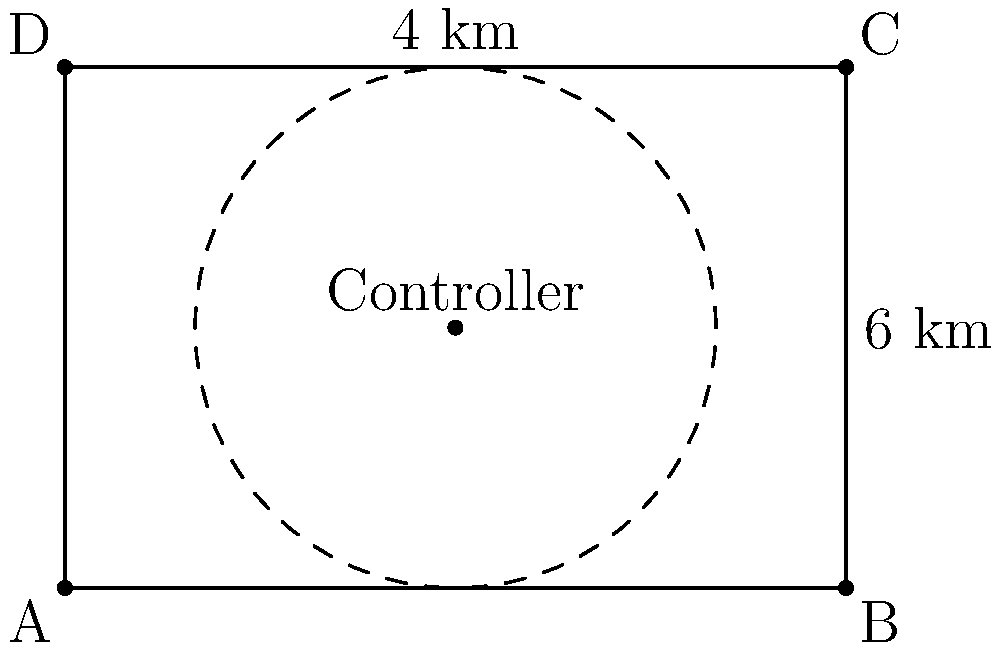In a rectangular SDN deployment area measuring 6 km by 4 km, a single SDN controller is placed at the center. Assuming the controller can effectively manage switches within a 2 km radius, what percentage of the total area is covered by the controller? Round your answer to the nearest whole percent. To solve this problem, we need to follow these steps:

1. Calculate the total area of the rectangle:
   Area of rectangle = length × width
   $A_{rectangle} = 6 \text{ km} \times 4 \text{ km} = 24 \text{ km}^2$

2. Calculate the area covered by the controller:
   The controller covers a circular area with a radius of 2 km.
   Area of circle = $\pi r^2$
   $A_{circle} = \pi \times (2 \text{ km})^2 = 4\pi \text{ km}^2$

3. However, we need to consider that parts of this circle extend beyond the rectangle. The entire circle fits within the rectangle, so we don't need to make any adjustments.

4. Calculate the percentage of area covered:
   Percentage = (Area covered / Total area) × 100
   $\text{Percentage} = \frac{4\pi \text{ km}^2}{24 \text{ km}^2} \times 100$

5. Simplify and calculate:
   $\text{Percentage} = \frac{\pi}{6} \times 100 \approx 52.36\%$

6. Round to the nearest whole percent:
   52.36% rounds to 52%

This coverage demonstrates the importance of optimal controller placement in SDN deployments to maximize network coverage and minimize latency.
Answer: 52% 